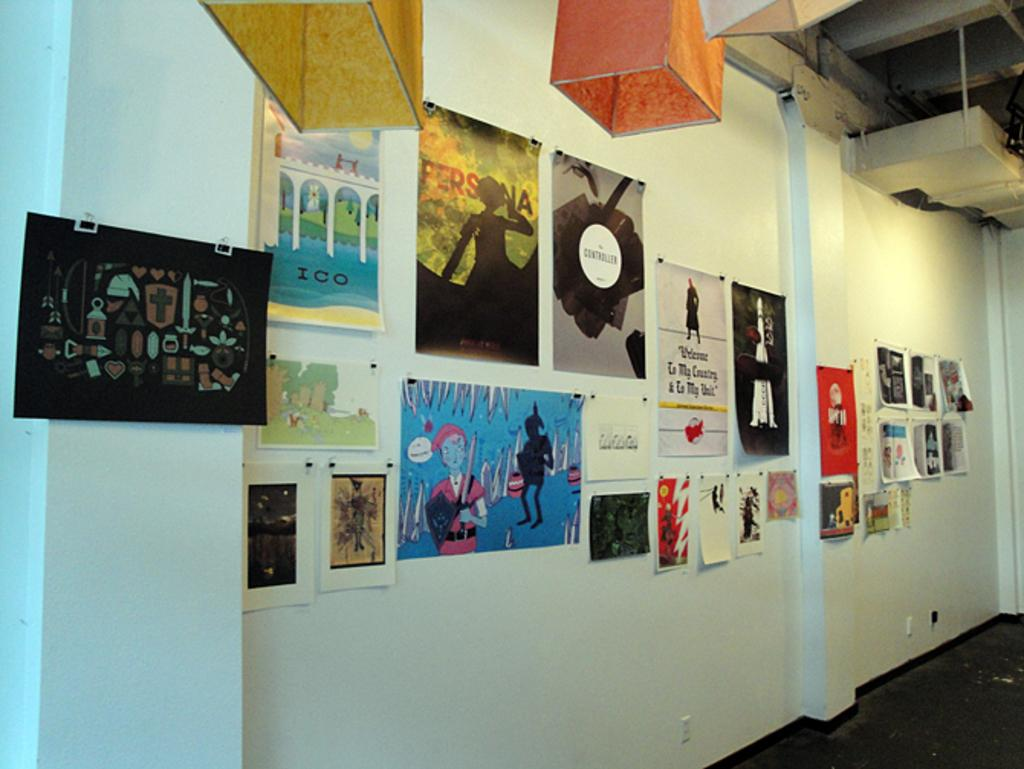What type of surface is visible at the bottom of the image? There is a floor in the image. What can be seen on the wall in the image? There are posters on the wall in the image. What is located near the wall in the image? There are objects near the wall in the image. Can you see a playground in the image? There is no mention of a playground in the image, so it cannot be confirmed. 